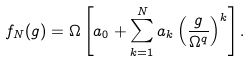<formula> <loc_0><loc_0><loc_500><loc_500>f _ { N } ( g ) = \Omega \left [ a _ { 0 } + \sum _ { k = 1 } ^ { N } a _ { k } \left ( \frac { g } { \Omega ^ { q } } \right ) ^ { k } \right ] .</formula> 